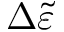<formula> <loc_0><loc_0><loc_500><loc_500>\Delta \widetilde { \varepsilon }</formula> 